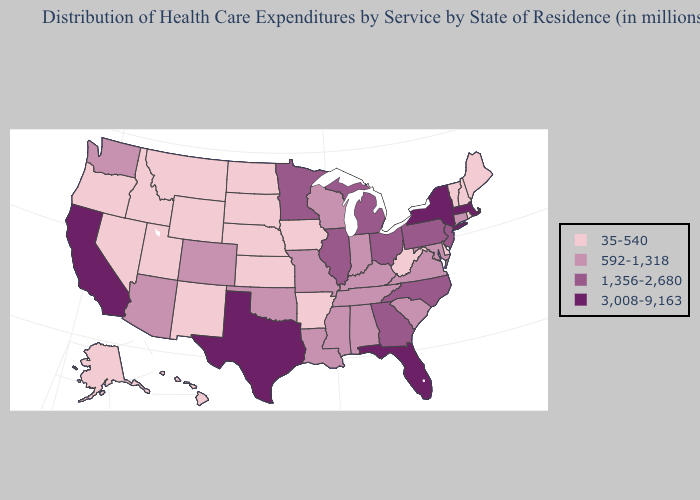What is the lowest value in the West?
Be succinct. 35-540. What is the highest value in the South ?
Concise answer only. 3,008-9,163. Does the first symbol in the legend represent the smallest category?
Keep it brief. Yes. What is the highest value in states that border Washington?
Answer briefly. 35-540. What is the value of North Carolina?
Keep it brief. 1,356-2,680. Which states have the highest value in the USA?
Give a very brief answer. California, Florida, Massachusetts, New York, Texas. Name the states that have a value in the range 1,356-2,680?
Keep it brief. Georgia, Illinois, Michigan, Minnesota, New Jersey, North Carolina, Ohio, Pennsylvania. Is the legend a continuous bar?
Concise answer only. No. Name the states that have a value in the range 3,008-9,163?
Quick response, please. California, Florida, Massachusetts, New York, Texas. Which states have the highest value in the USA?
Write a very short answer. California, Florida, Massachusetts, New York, Texas. What is the highest value in states that border South Carolina?
Keep it brief. 1,356-2,680. Which states have the lowest value in the MidWest?
Keep it brief. Iowa, Kansas, Nebraska, North Dakota, South Dakota. Name the states that have a value in the range 1,356-2,680?
Keep it brief. Georgia, Illinois, Michigan, Minnesota, New Jersey, North Carolina, Ohio, Pennsylvania. Name the states that have a value in the range 3,008-9,163?
Short answer required. California, Florida, Massachusetts, New York, Texas. What is the lowest value in states that border New Hampshire?
Answer briefly. 35-540. 